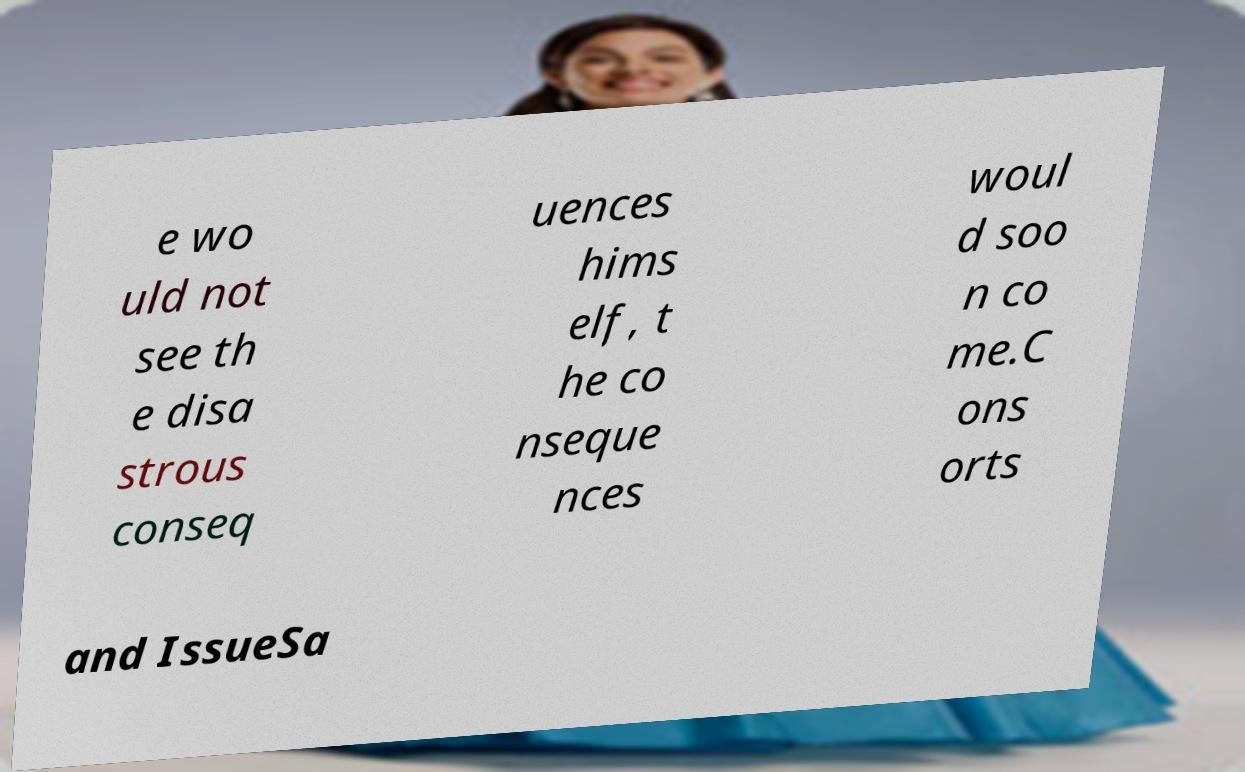Could you assist in decoding the text presented in this image and type it out clearly? e wo uld not see th e disa strous conseq uences hims elf, t he co nseque nces woul d soo n co me.C ons orts and IssueSa 